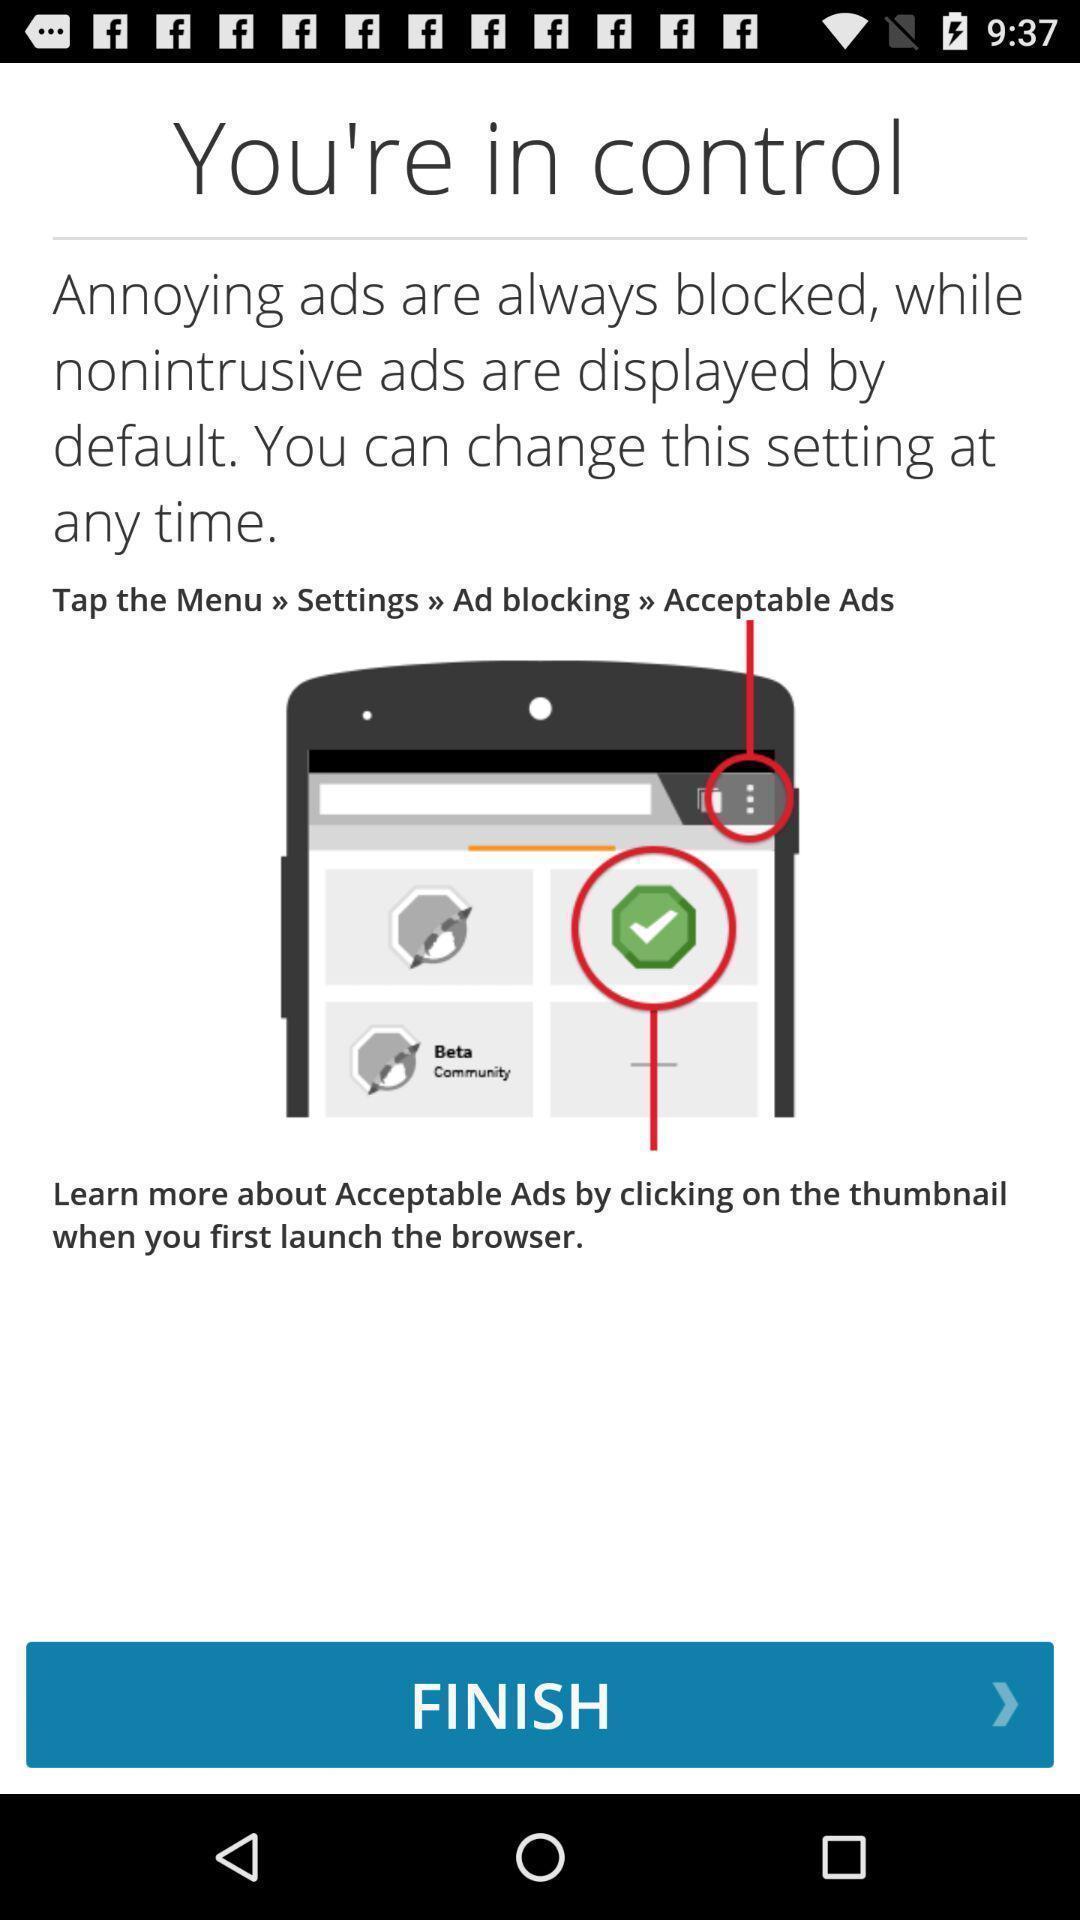Summarize the information in this screenshot. Page that displaying learn more about acceptable. 